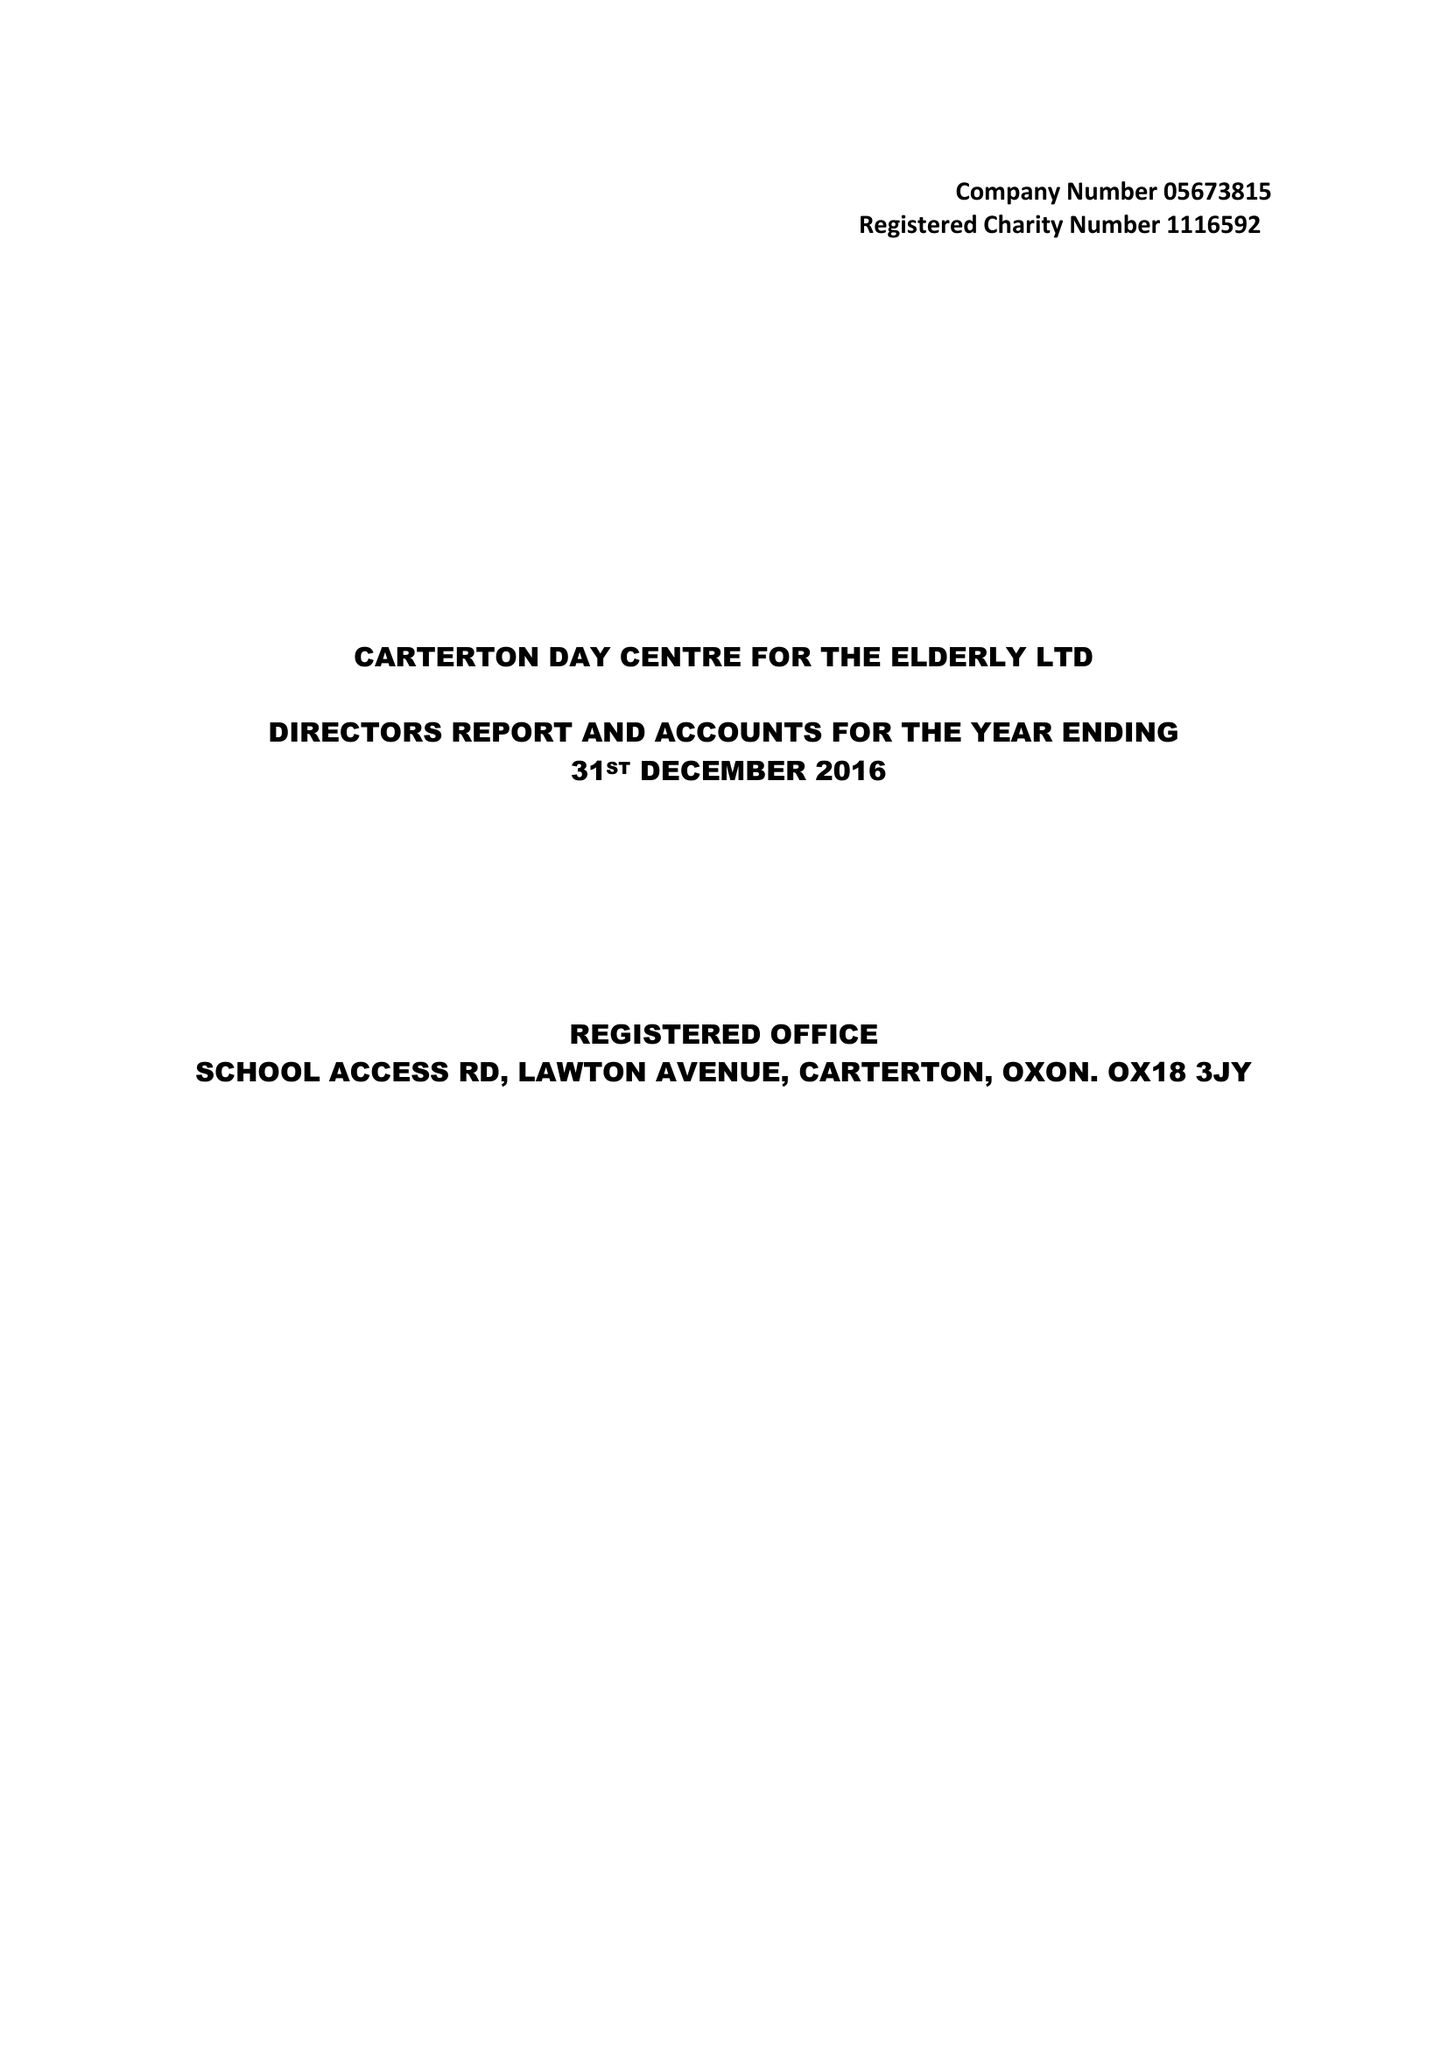What is the value for the address__street_line?
Answer the question using a single word or phrase. LAWTON AVENUE 